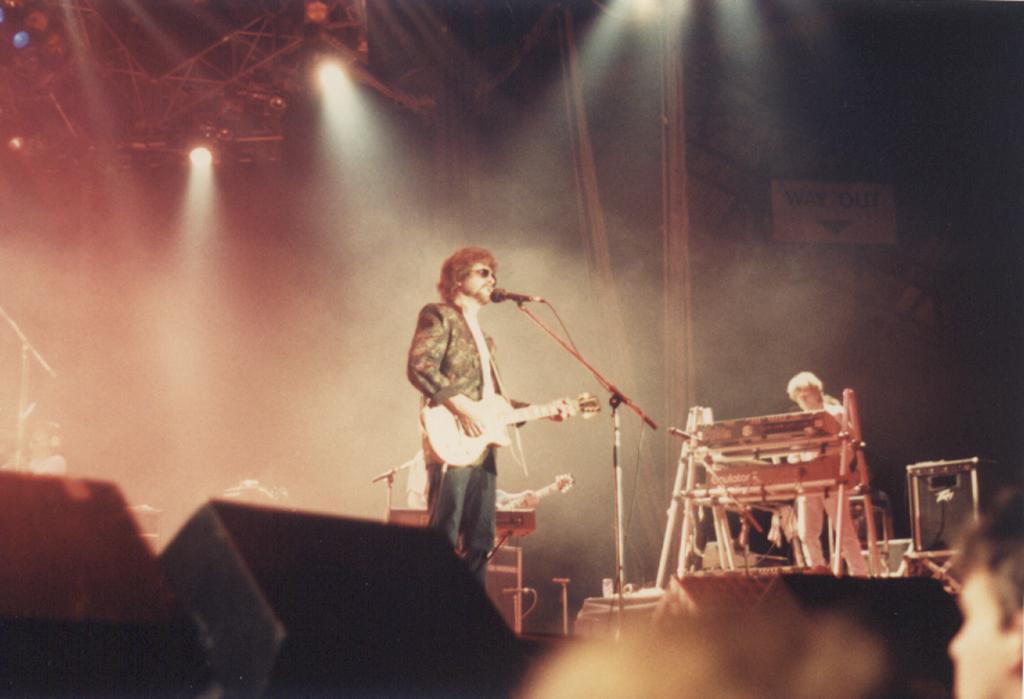How would you summarize this image in a sentence or two? This picture shows a man standing and holding a guitar in his hand and we see a microphone in front of him and we see a man playing piano and we see other man playing guitar on his back and we see few lights on the roof and audience watching 